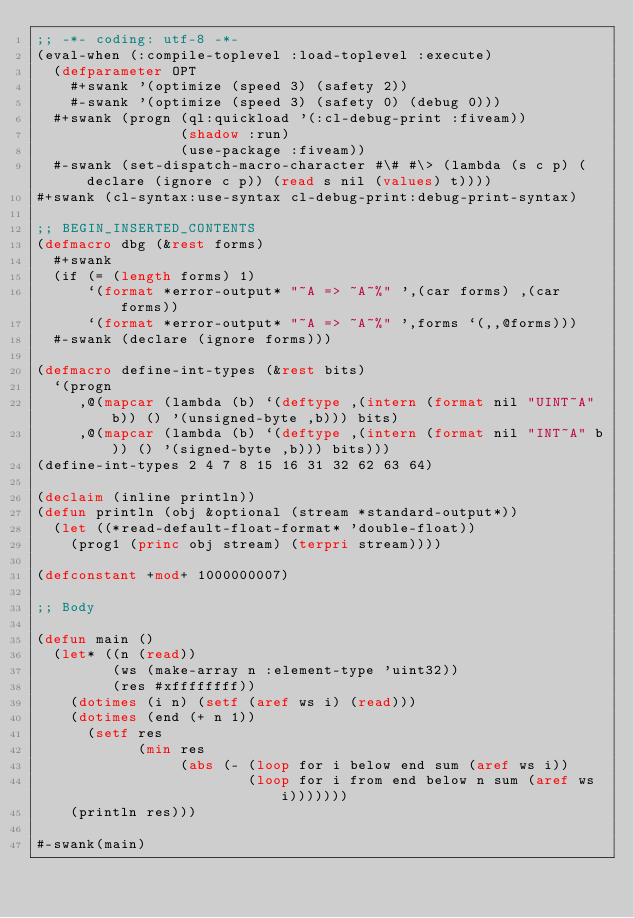Convert code to text. <code><loc_0><loc_0><loc_500><loc_500><_Lisp_>;; -*- coding: utf-8 -*-
(eval-when (:compile-toplevel :load-toplevel :execute)
  (defparameter OPT
    #+swank '(optimize (speed 3) (safety 2))
    #-swank '(optimize (speed 3) (safety 0) (debug 0)))
  #+swank (progn (ql:quickload '(:cl-debug-print :fiveam))
                 (shadow :run)
                 (use-package :fiveam))
  #-swank (set-dispatch-macro-character #\# #\> (lambda (s c p) (declare (ignore c p)) (read s nil (values) t))))
#+swank (cl-syntax:use-syntax cl-debug-print:debug-print-syntax)

;; BEGIN_INSERTED_CONTENTS
(defmacro dbg (&rest forms)
  #+swank
  (if (= (length forms) 1)
      `(format *error-output* "~A => ~A~%" ',(car forms) ,(car forms))
      `(format *error-output* "~A => ~A~%" ',forms `(,,@forms)))
  #-swank (declare (ignore forms)))

(defmacro define-int-types (&rest bits)
  `(progn
     ,@(mapcar (lambda (b) `(deftype ,(intern (format nil "UINT~A" b)) () '(unsigned-byte ,b))) bits)
     ,@(mapcar (lambda (b) `(deftype ,(intern (format nil "INT~A" b)) () '(signed-byte ,b))) bits)))
(define-int-types 2 4 7 8 15 16 31 32 62 63 64)

(declaim (inline println))
(defun println (obj &optional (stream *standard-output*))
  (let ((*read-default-float-format* 'double-float))
    (prog1 (princ obj stream) (terpri stream))))

(defconstant +mod+ 1000000007)

;; Body

(defun main ()
  (let* ((n (read))
         (ws (make-array n :element-type 'uint32))
         (res #xffffffff))
    (dotimes (i n) (setf (aref ws i) (read)))
    (dotimes (end (+ n 1))
      (setf res
            (min res
                 (abs (- (loop for i below end sum (aref ws i))
                         (loop for i from end below n sum (aref ws i)))))))
    (println res)))

#-swank(main)
</code> 